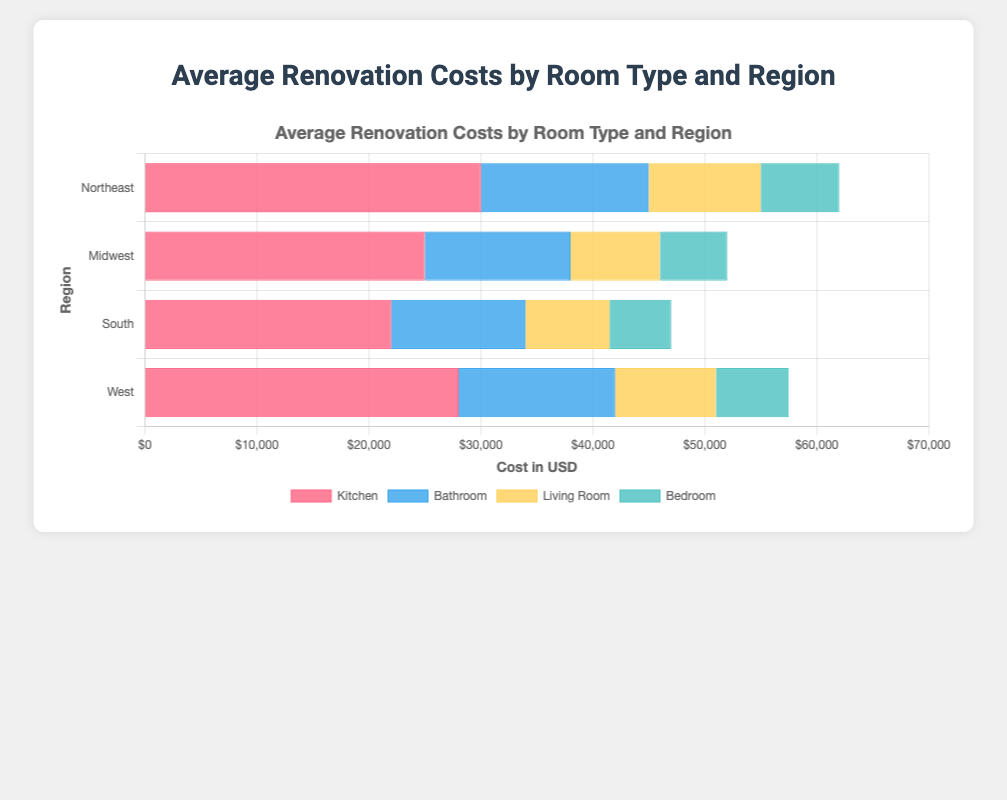What is the average cost of renovating a Kitchen in all regions? To find the average cost of renovating a Kitchen in all regions, add up the costs from all regions and divide by the number of regions. The costs are $30000 (Northeast), $25000 (Midwest), $22000 (South), and $28000 (West). Sum = $30000 + $25000 + $22000 + $28000 = $105000. Dividing by 4 regions, the average is $105000 / 4 = $26250.
Answer: $26250 Which region has the highest renovation cost for a Bathroom? Look at the bar lengths associated with Bathroom costs in each region. The Northeast has $15000, the Midwest has $13000, the South has $12000, and the West has $14000. The highest cost is $15000 in the Northeast.
Answer: Northeast Which room type has the lowest renovation cost in the South? Compare the bar lengths (costs) for each room type in the South: Kitchen ($22000), Bathroom ($12000), Living Room ($7500), Bedroom ($5500). The lowest cost is $5500 for the Bedroom.
Answer: Bedroom What is the total renovation cost for the Northeast region across all room types? Add the renovation costs for all room types in the Northeast: Kitchen ($30000), Bathroom ($15000), Living Room ($10000), Bedroom ($7000). Total = $30000 + $15000 + $10000 + $7000 = $62000.
Answer: $62000 How much more does it cost to renovate a Kitchen than a Living Room in the Midwest? Subtract the cost of renovating a Living Room from the cost of renovating a Kitchen in the Midwest. Costs are $25000 (Kitchen) and $8000 (Living Room). Difference = $25000 - $8000 = $17000.
Answer: $17000 In which region is the cost difference between Bathroom and Bedroom renovations the largest? Calculate the difference between Bathroom and Bedroom renovations for each region: Northeast ($15000 - $7000 = $8000), Midwest ($13000 - $6000 = $7000), South ($12000 - $5500 = $6500), West ($14000 - $6500 = $7500). The largest difference is $8000 in the Northeast.
Answer: Northeast What is the combined renovation cost for a Living Room and Bedroom in the West? Add the costs for renovating a Living Room and a Bedroom in the West: Living Room ($9000) and Bedroom ($6500). Combined cost = $9000 + $6500 = $15500.
Answer: $15500 Which room type has the smallest cost variation across regions? Look at the bar lengths for each room type across all regions and identify the one with the smallest differences. Kitchen ($8000 difference), Bathroom ($3000 difference), Living Room ($2500 difference), Bedroom ($2000 difference). The Bedroom has the smallest cost variation at $2000.
Answer: Bedroom What is the average renovation cost for a Living Room across the Midwest and South? Add the costs of renovating a Living Room in the Midwest and South, then divide by 2. Costs are $8000 (Midwest) and $7500 (South). Average = ($8000 + $7500) / 2 = $7750.
Answer: $7750 